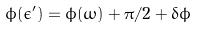<formula> <loc_0><loc_0><loc_500><loc_500>\phi ( \epsilon ^ { \prime } ) = \phi ( \omega ) + \pi / 2 + \delta \phi</formula> 